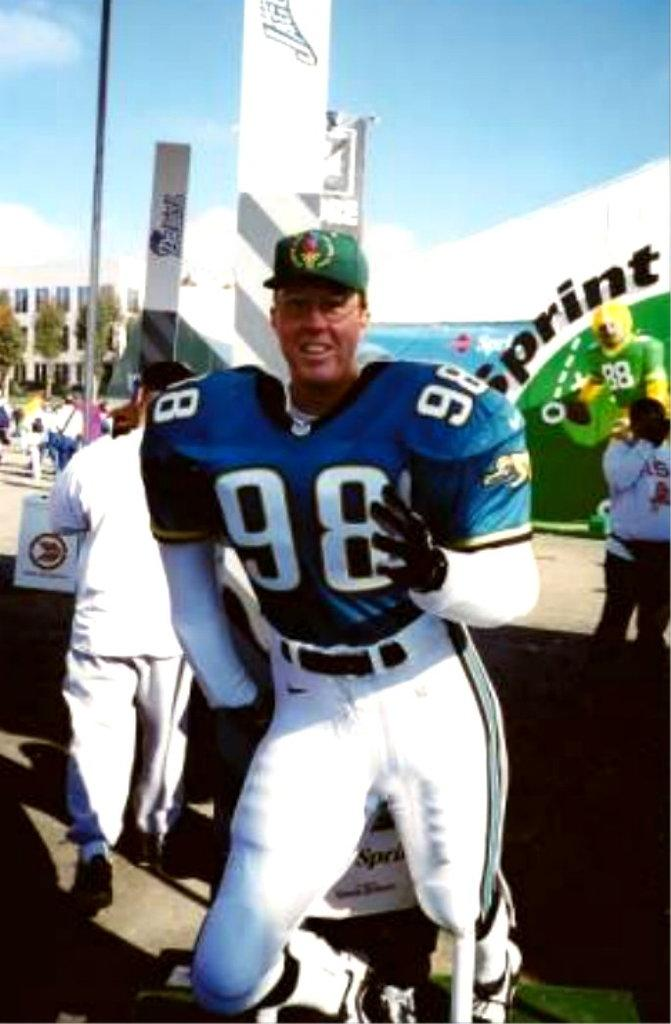<image>
Share a concise interpretation of the image provided. A man wearing a jersey number 98 has a green hat on. 